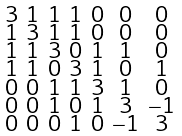Convert formula to latex. <formula><loc_0><loc_0><loc_500><loc_500>\begin{smallmatrix} 3 & 1 & 1 & 1 & 0 & 0 & 0 \\ 1 & 3 & 1 & 1 & 0 & 0 & 0 \\ 1 & 1 & 3 & 0 & 1 & 1 & 0 \\ 1 & 1 & 0 & 3 & 1 & 0 & 1 \\ 0 & 0 & 1 & 1 & 3 & 1 & 0 \\ 0 & 0 & 1 & 0 & 1 & 3 & - 1 \\ 0 & 0 & 0 & 1 & 0 & - 1 & 3 \end{smallmatrix}</formula> 